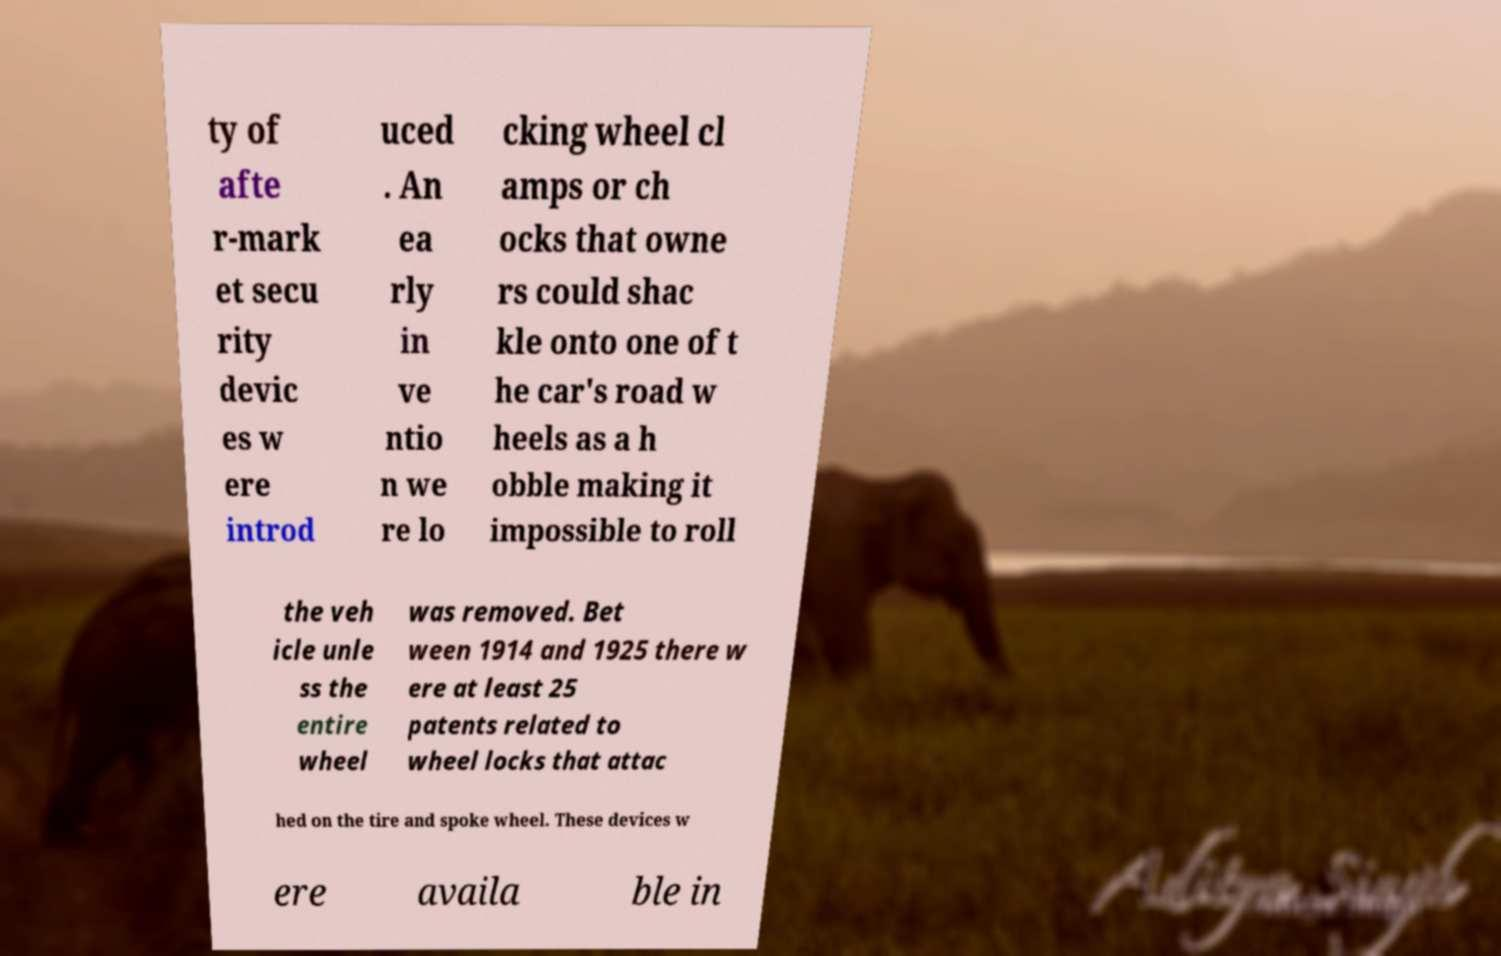Could you assist in decoding the text presented in this image and type it out clearly? ty of afte r-mark et secu rity devic es w ere introd uced . An ea rly in ve ntio n we re lo cking wheel cl amps or ch ocks that owne rs could shac kle onto one of t he car's road w heels as a h obble making it impossible to roll the veh icle unle ss the entire wheel was removed. Bet ween 1914 and 1925 there w ere at least 25 patents related to wheel locks that attac hed on the tire and spoke wheel. These devices w ere availa ble in 